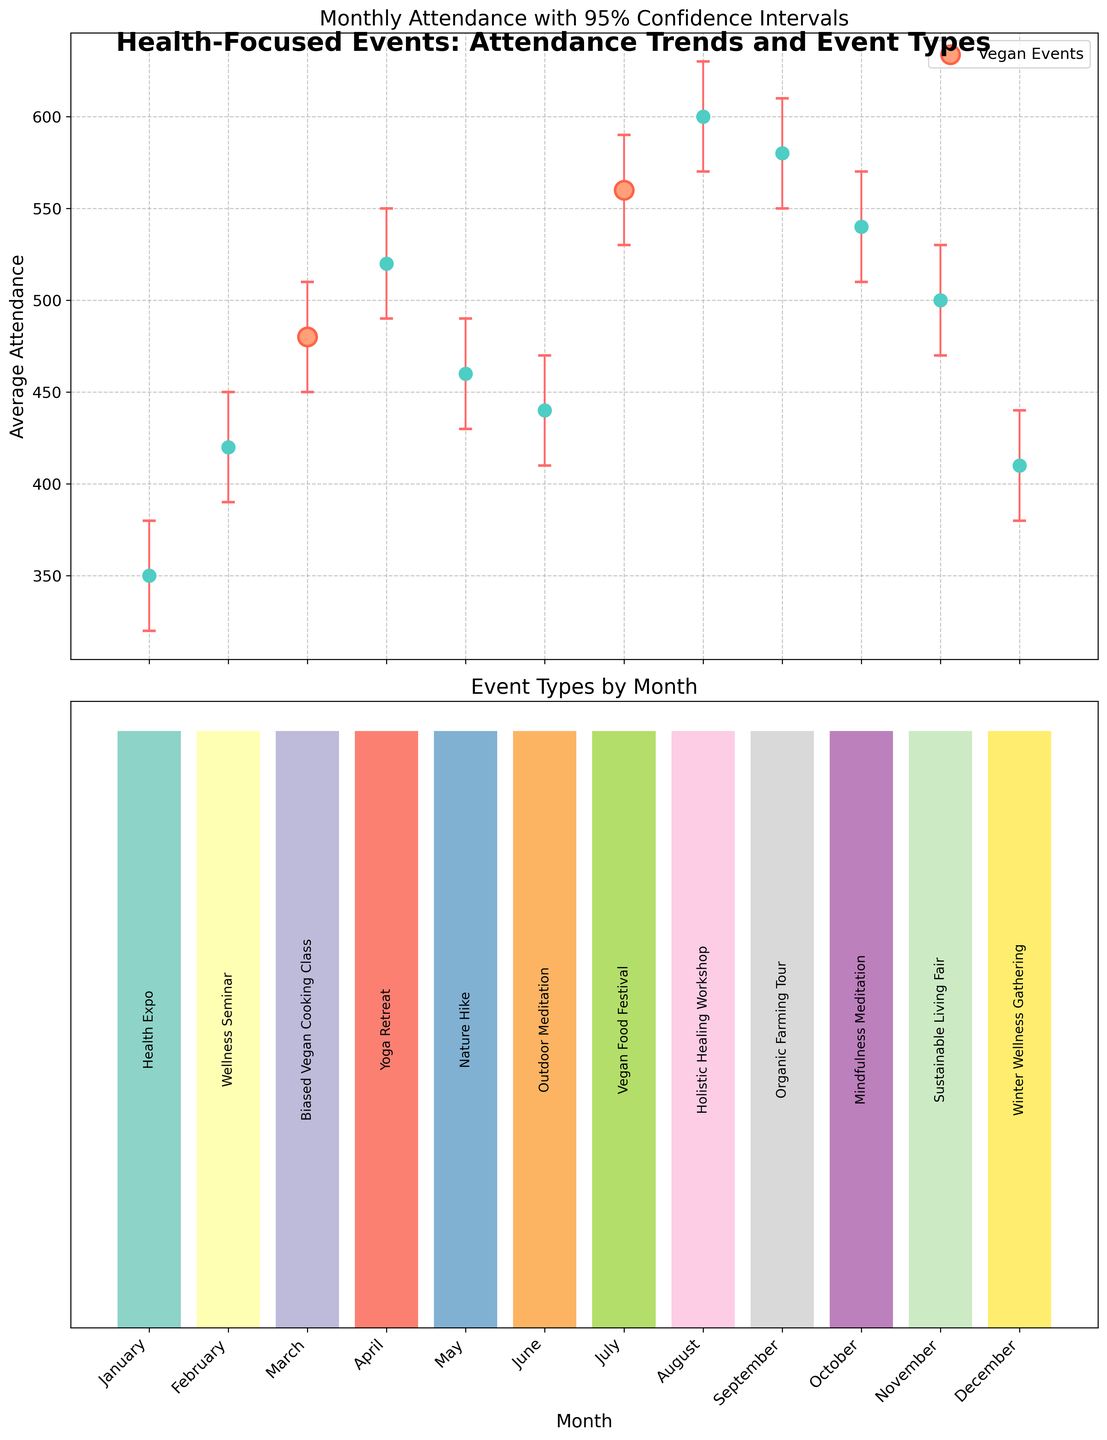What is the title of the first plot? The title of a plot is typically located at the top. The title helps the reader understand what the plot is about. In this case, the title is "Monthly Attendance with 95% Confidence Intervals."
Answer: Monthly Attendance with 95% Confidence Intervals Which months have vegan events, and how are they visually distinguished? Vegan events are highlighted as special points in the first plot with distinct markers. The months corresponding to vegan events are March and July, indicated by scatter points colored differently from the others.
Answer: March and July What is the average attendance for the Health Expo in January? The plot uses markers to indicate the average attendance per month. For January, the Health Expo's attendance value is directly labeled and colored on the chart. The average attendance is 350.
Answer: 350 Which month had the highest average attendance, and during which event? To find the highest average attendance, look at all the plotted points and their corresponding y-values. The highest point is in August, indicating an average attendance of 600 during the Holistic Healing Workshop.
Answer: August, Holistic Healing Workshop Are there any months where the 95% confidence interval does not overlap with the month before? Confidence intervals are visualized as vertical bars around each point. Look for where these intervals do not touch or overlap. Between July and August, the intervals do not overlap.
Answer: Between July and August Which event type has the largest average attendance, and what is the value? The event type can be inferred from the plot and annotated information. The highest average attendance is for the Holistic Healing Workshop in August, and the value is 600.
Answer: Holistic Healing Workshop, 600 What is the average attendance difference between the lowest month and the highest month? The lowest attendance is in January (350) and the highest in August (600). The difference can be calculated as 600 - 350 = 250.
Answer: 250 Is there a month where attendance significantly drops from the previous month? A significant drop can be identified by a steep decline between points. From October (540) to December (410), there is a noticeable drop in attendance.
Answer: From October to December What are the 95% confidence interval bounds for the July Vegan Food Festival? The vertical error bars show the range of the confidence interval. For July, the bounds are from 530 to 590.
Answer: 530 to 590 Which event has the narrowest 95% confidence interval, and what are the bounds? The narrowest interval has the smallest distance between upper and lower bounds. For January's Health Expo, the interval is narrowest and is from 320 to 380.
Answer: Health Expo in January, 320 to 380 